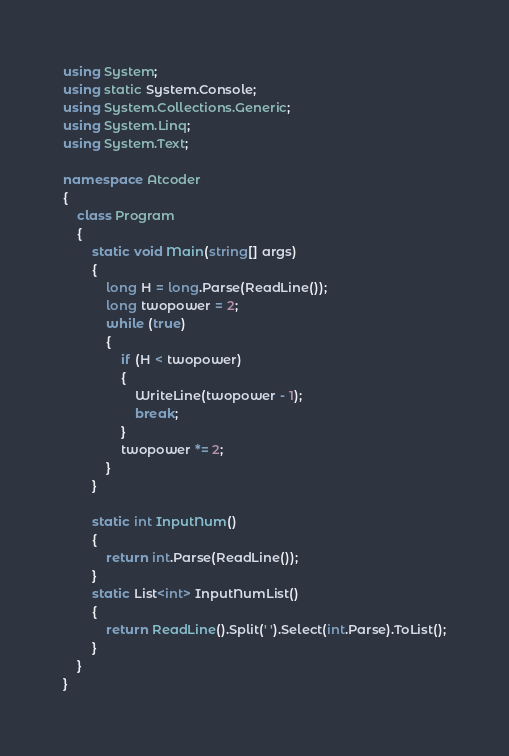Convert code to text. <code><loc_0><loc_0><loc_500><loc_500><_C#_>using System;
using static System.Console;
using System.Collections.Generic;
using System.Linq;
using System.Text;

namespace Atcoder
{
    class Program
    {
        static void Main(string[] args)
        {
            long H = long.Parse(ReadLine());
            long twopower = 2;
            while (true)
            {
                if (H < twopower)
                {
                    WriteLine(twopower - 1);
                    break;
                }
                twopower *= 2;
            }
        }

        static int InputNum()
        {
            return int.Parse(ReadLine());
        }
        static List<int> InputNumList()
        {
            return ReadLine().Split(' ').Select(int.Parse).ToList();
        }
    }
}</code> 